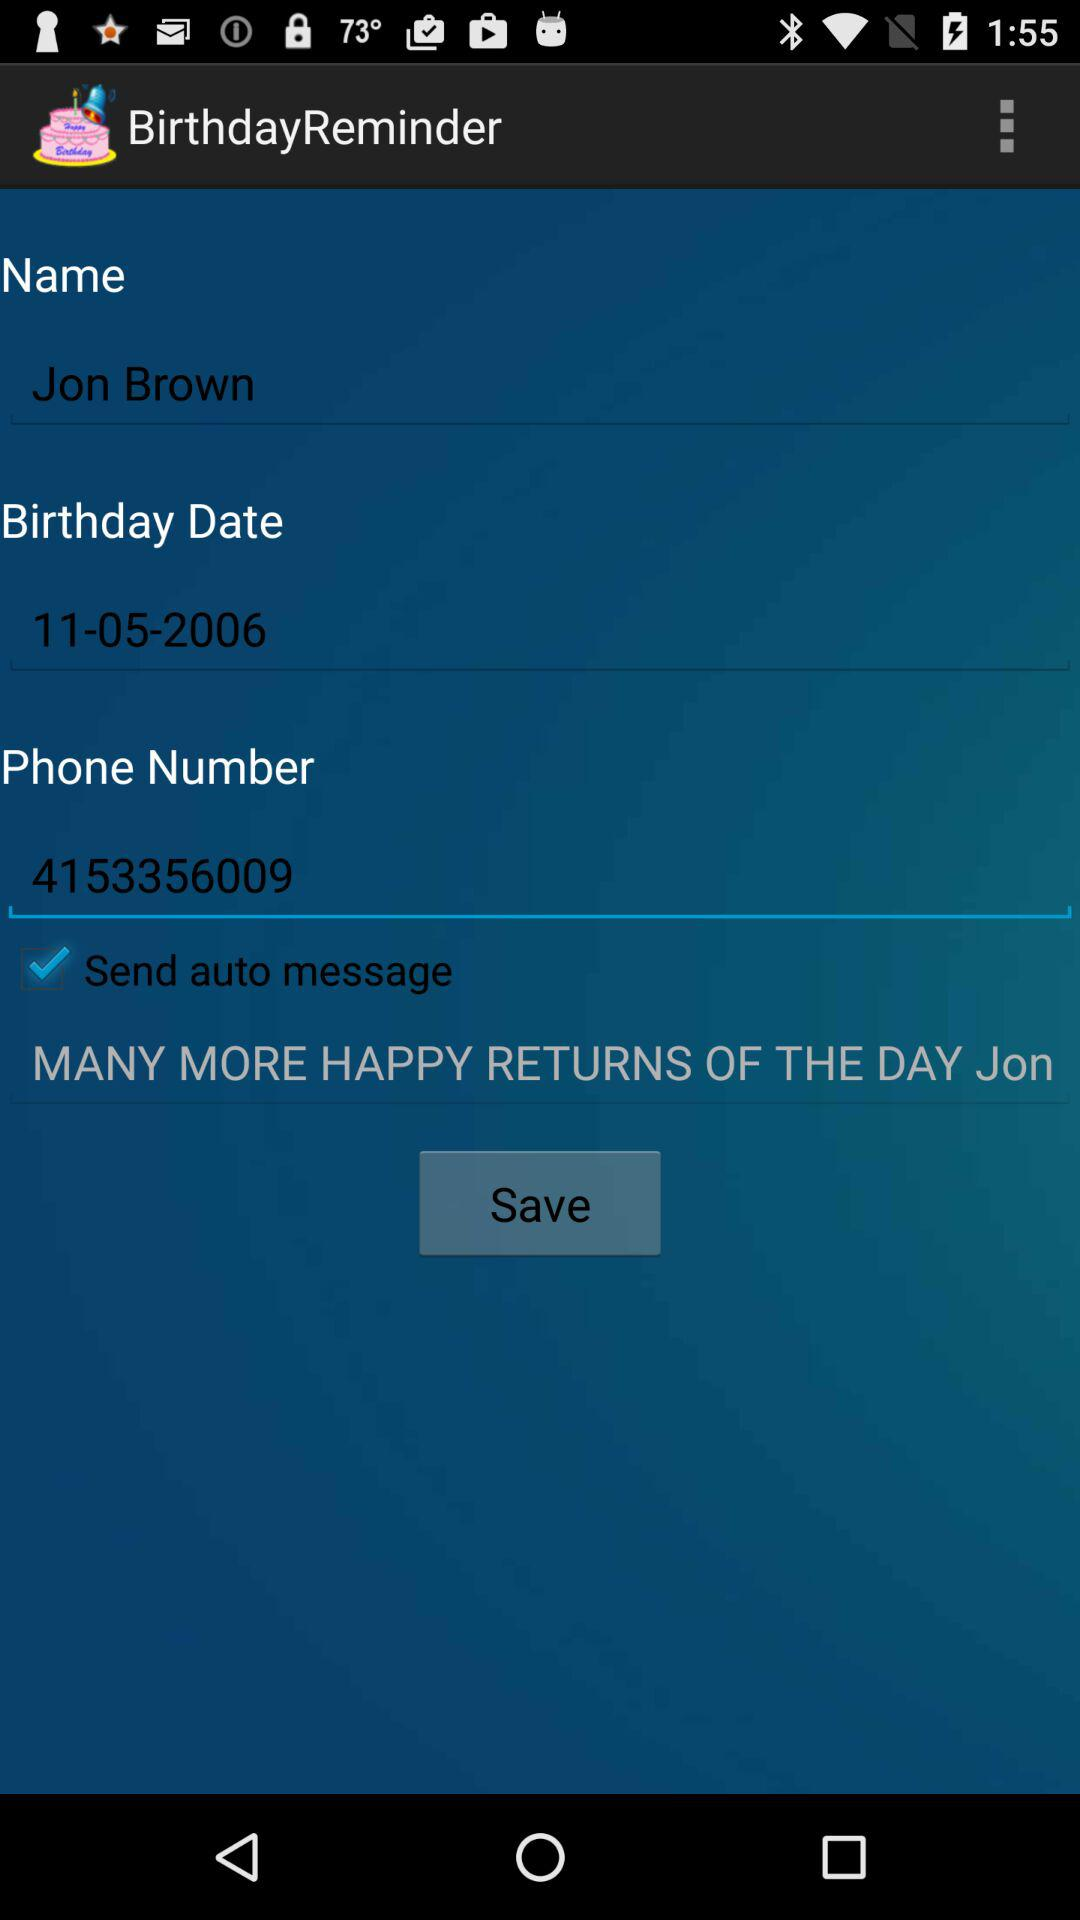What's the date of birth? The date of birth is November 5, 2006. 